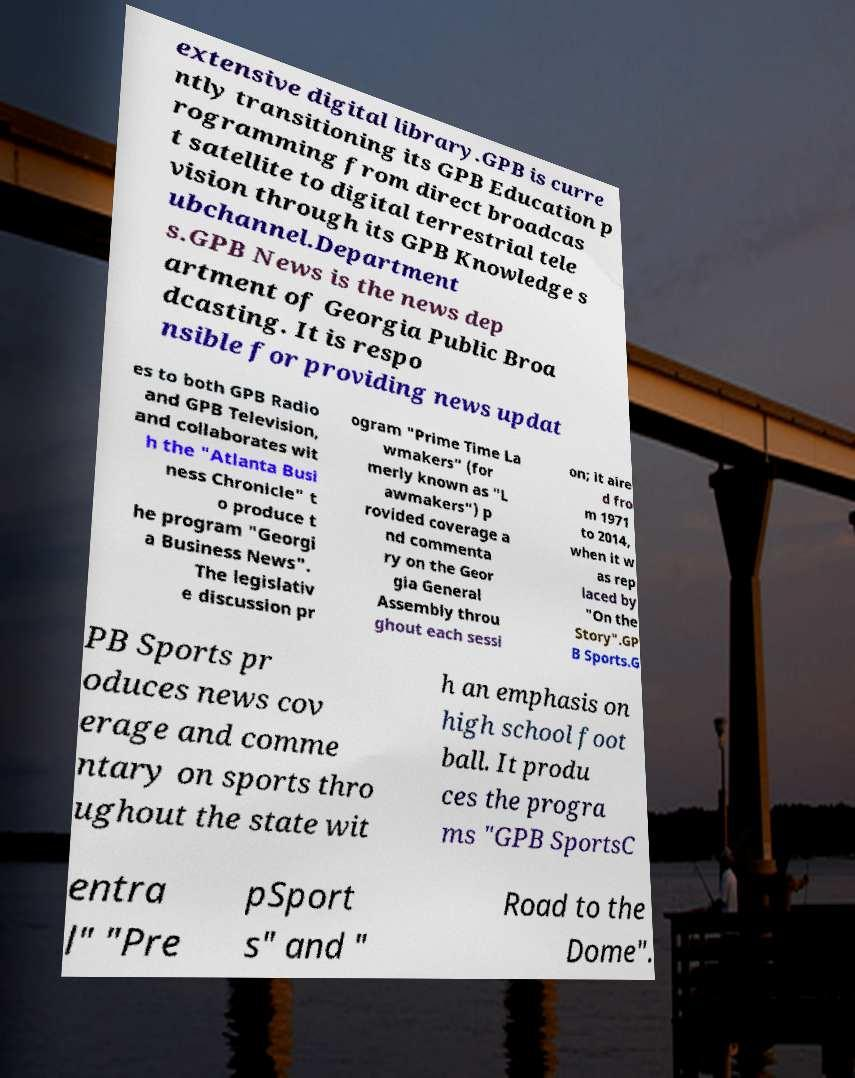Could you extract and type out the text from this image? extensive digital library.GPB is curre ntly transitioning its GPB Education p rogramming from direct broadcas t satellite to digital terrestrial tele vision through its GPB Knowledge s ubchannel.Department s.GPB News is the news dep artment of Georgia Public Broa dcasting. It is respo nsible for providing news updat es to both GPB Radio and GPB Television, and collaborates wit h the "Atlanta Busi ness Chronicle" t o produce t he program "Georgi a Business News". The legislativ e discussion pr ogram "Prime Time La wmakers" (for merly known as "L awmakers") p rovided coverage a nd commenta ry on the Geor gia General Assembly throu ghout each sessi on; it aire d fro m 1971 to 2014, when it w as rep laced by "On the Story".GP B Sports.G PB Sports pr oduces news cov erage and comme ntary on sports thro ughout the state wit h an emphasis on high school foot ball. It produ ces the progra ms "GPB SportsC entra l" "Pre pSport s" and " Road to the Dome". 